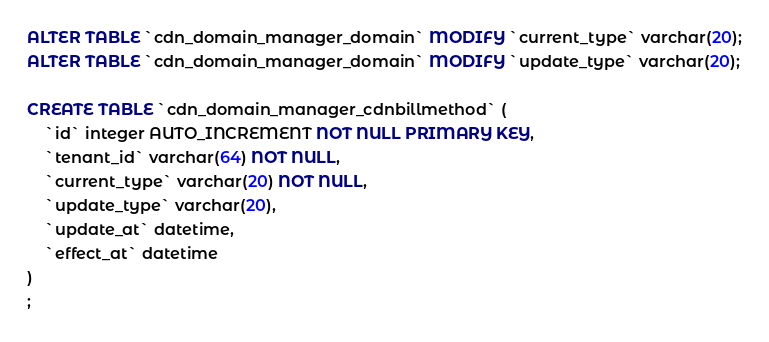Convert code to text. <code><loc_0><loc_0><loc_500><loc_500><_SQL_>ALTER TABLE `cdn_domain_manager_domain` MODIFY `current_type` varchar(20);
ALTER TABLE `cdn_domain_manager_domain` MODIFY `update_type` varchar(20);

CREATE TABLE `cdn_domain_manager_cdnbillmethod` (
    `id` integer AUTO_INCREMENT NOT NULL PRIMARY KEY,
    `tenant_id` varchar(64) NOT NULL,
    `current_type` varchar(20) NOT NULL,
    `update_type` varchar(20),
    `update_at` datetime,
    `effect_at` datetime
)
;
</code> 